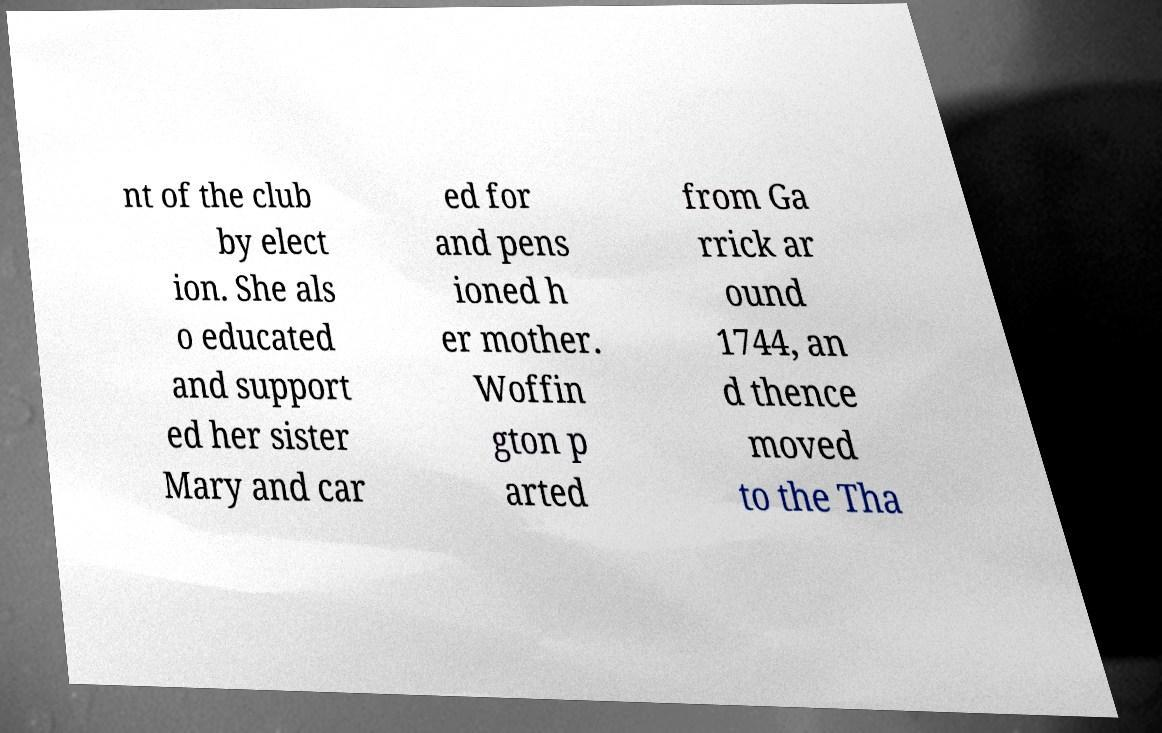Please identify and transcribe the text found in this image. nt of the club by elect ion. She als o educated and support ed her sister Mary and car ed for and pens ioned h er mother. Woffin gton p arted from Ga rrick ar ound 1744, an d thence moved to the Tha 